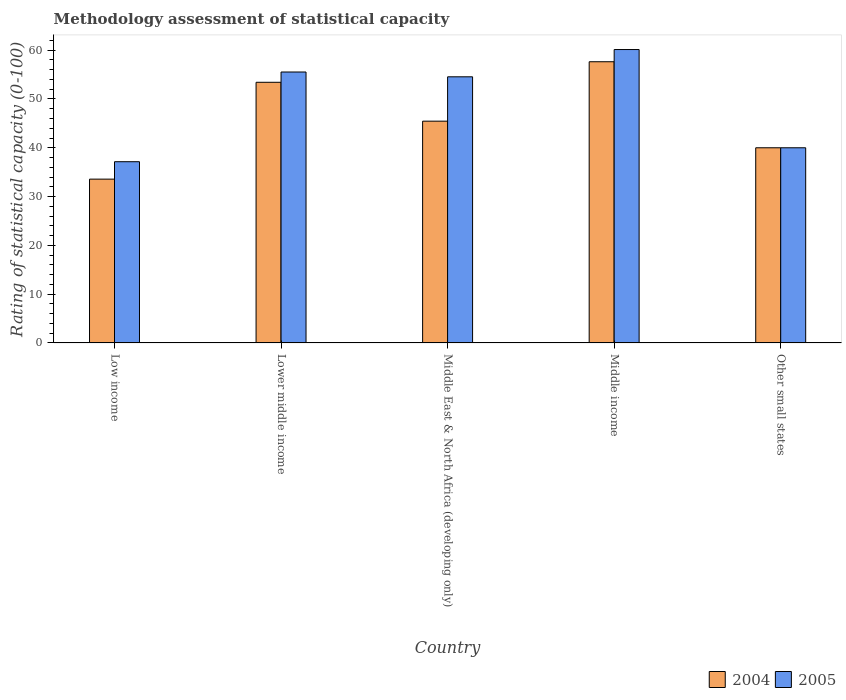How many different coloured bars are there?
Your response must be concise. 2. Are the number of bars per tick equal to the number of legend labels?
Provide a succinct answer. Yes. How many bars are there on the 5th tick from the left?
Offer a terse response. 2. How many bars are there on the 4th tick from the right?
Offer a terse response. 2. What is the label of the 5th group of bars from the left?
Keep it short and to the point. Other small states. In how many cases, is the number of bars for a given country not equal to the number of legend labels?
Provide a short and direct response. 0. What is the rating of statistical capacity in 2005 in Lower middle income?
Provide a short and direct response. 55.53. Across all countries, what is the maximum rating of statistical capacity in 2004?
Provide a short and direct response. 57.63. Across all countries, what is the minimum rating of statistical capacity in 2005?
Provide a succinct answer. 37.14. In which country was the rating of statistical capacity in 2004 maximum?
Your answer should be very brief. Middle income. In which country was the rating of statistical capacity in 2004 minimum?
Provide a succinct answer. Low income. What is the total rating of statistical capacity in 2004 in the graph?
Offer a very short reply. 230.08. What is the difference between the rating of statistical capacity in 2004 in Lower middle income and that in Middle income?
Keep it short and to the point. -4.21. What is the difference between the rating of statistical capacity in 2005 in Middle East & North Africa (developing only) and the rating of statistical capacity in 2004 in Lower middle income?
Keep it short and to the point. 1.12. What is the average rating of statistical capacity in 2004 per country?
Your answer should be compact. 46.02. What is the difference between the rating of statistical capacity of/in 2005 and rating of statistical capacity of/in 2004 in Lower middle income?
Keep it short and to the point. 2.11. In how many countries, is the rating of statistical capacity in 2005 greater than 18?
Keep it short and to the point. 5. What is the ratio of the rating of statistical capacity in 2004 in Middle East & North Africa (developing only) to that in Middle income?
Your answer should be compact. 0.79. Is the rating of statistical capacity in 2005 in Low income less than that in Middle income?
Keep it short and to the point. Yes. Is the difference between the rating of statistical capacity in 2005 in Middle income and Other small states greater than the difference between the rating of statistical capacity in 2004 in Middle income and Other small states?
Your answer should be compact. Yes. What is the difference between the highest and the second highest rating of statistical capacity in 2004?
Your answer should be very brief. 12.18. What is the difference between the highest and the lowest rating of statistical capacity in 2005?
Provide a succinct answer. 22.99. Is the sum of the rating of statistical capacity in 2004 in Low income and Lower middle income greater than the maximum rating of statistical capacity in 2005 across all countries?
Offer a very short reply. Yes. How many bars are there?
Make the answer very short. 10. What is the difference between two consecutive major ticks on the Y-axis?
Ensure brevity in your answer.  10. Are the values on the major ticks of Y-axis written in scientific E-notation?
Provide a short and direct response. No. Does the graph contain any zero values?
Provide a short and direct response. No. Where does the legend appear in the graph?
Provide a short and direct response. Bottom right. What is the title of the graph?
Your answer should be compact. Methodology assessment of statistical capacity. What is the label or title of the Y-axis?
Your response must be concise. Rating of statistical capacity (0-100). What is the Rating of statistical capacity (0-100) in 2004 in Low income?
Your answer should be compact. 33.57. What is the Rating of statistical capacity (0-100) of 2005 in Low income?
Give a very brief answer. 37.14. What is the Rating of statistical capacity (0-100) of 2004 in Lower middle income?
Provide a short and direct response. 53.42. What is the Rating of statistical capacity (0-100) in 2005 in Lower middle income?
Keep it short and to the point. 55.53. What is the Rating of statistical capacity (0-100) of 2004 in Middle East & North Africa (developing only)?
Offer a very short reply. 45.45. What is the Rating of statistical capacity (0-100) in 2005 in Middle East & North Africa (developing only)?
Give a very brief answer. 54.55. What is the Rating of statistical capacity (0-100) of 2004 in Middle income?
Give a very brief answer. 57.63. What is the Rating of statistical capacity (0-100) in 2005 in Middle income?
Your answer should be very brief. 60.13. What is the Rating of statistical capacity (0-100) in 2004 in Other small states?
Your answer should be very brief. 40. What is the Rating of statistical capacity (0-100) of 2005 in Other small states?
Give a very brief answer. 40. Across all countries, what is the maximum Rating of statistical capacity (0-100) in 2004?
Provide a succinct answer. 57.63. Across all countries, what is the maximum Rating of statistical capacity (0-100) of 2005?
Provide a short and direct response. 60.13. Across all countries, what is the minimum Rating of statistical capacity (0-100) in 2004?
Give a very brief answer. 33.57. Across all countries, what is the minimum Rating of statistical capacity (0-100) of 2005?
Provide a succinct answer. 37.14. What is the total Rating of statistical capacity (0-100) of 2004 in the graph?
Offer a very short reply. 230.08. What is the total Rating of statistical capacity (0-100) in 2005 in the graph?
Keep it short and to the point. 247.35. What is the difference between the Rating of statistical capacity (0-100) of 2004 in Low income and that in Lower middle income?
Give a very brief answer. -19.85. What is the difference between the Rating of statistical capacity (0-100) of 2005 in Low income and that in Lower middle income?
Your answer should be very brief. -18.38. What is the difference between the Rating of statistical capacity (0-100) in 2004 in Low income and that in Middle East & North Africa (developing only)?
Your answer should be very brief. -11.88. What is the difference between the Rating of statistical capacity (0-100) in 2005 in Low income and that in Middle East & North Africa (developing only)?
Ensure brevity in your answer.  -17.4. What is the difference between the Rating of statistical capacity (0-100) of 2004 in Low income and that in Middle income?
Your answer should be compact. -24.06. What is the difference between the Rating of statistical capacity (0-100) of 2005 in Low income and that in Middle income?
Provide a succinct answer. -22.99. What is the difference between the Rating of statistical capacity (0-100) in 2004 in Low income and that in Other small states?
Your response must be concise. -6.43. What is the difference between the Rating of statistical capacity (0-100) in 2005 in Low income and that in Other small states?
Offer a terse response. -2.86. What is the difference between the Rating of statistical capacity (0-100) of 2004 in Lower middle income and that in Middle East & North Africa (developing only)?
Ensure brevity in your answer.  7.97. What is the difference between the Rating of statistical capacity (0-100) of 2005 in Lower middle income and that in Middle East & North Africa (developing only)?
Offer a terse response. 0.98. What is the difference between the Rating of statistical capacity (0-100) in 2004 in Lower middle income and that in Middle income?
Offer a terse response. -4.21. What is the difference between the Rating of statistical capacity (0-100) of 2005 in Lower middle income and that in Middle income?
Your answer should be very brief. -4.61. What is the difference between the Rating of statistical capacity (0-100) in 2004 in Lower middle income and that in Other small states?
Your answer should be compact. 13.42. What is the difference between the Rating of statistical capacity (0-100) of 2005 in Lower middle income and that in Other small states?
Your response must be concise. 15.53. What is the difference between the Rating of statistical capacity (0-100) of 2004 in Middle East & North Africa (developing only) and that in Middle income?
Ensure brevity in your answer.  -12.18. What is the difference between the Rating of statistical capacity (0-100) in 2005 in Middle East & North Africa (developing only) and that in Middle income?
Your response must be concise. -5.59. What is the difference between the Rating of statistical capacity (0-100) of 2004 in Middle East & North Africa (developing only) and that in Other small states?
Make the answer very short. 5.45. What is the difference between the Rating of statistical capacity (0-100) of 2005 in Middle East & North Africa (developing only) and that in Other small states?
Make the answer very short. 14.55. What is the difference between the Rating of statistical capacity (0-100) of 2004 in Middle income and that in Other small states?
Your answer should be very brief. 17.63. What is the difference between the Rating of statistical capacity (0-100) of 2005 in Middle income and that in Other small states?
Your response must be concise. 20.13. What is the difference between the Rating of statistical capacity (0-100) in 2004 in Low income and the Rating of statistical capacity (0-100) in 2005 in Lower middle income?
Your answer should be compact. -21.95. What is the difference between the Rating of statistical capacity (0-100) in 2004 in Low income and the Rating of statistical capacity (0-100) in 2005 in Middle East & North Africa (developing only)?
Give a very brief answer. -20.97. What is the difference between the Rating of statistical capacity (0-100) of 2004 in Low income and the Rating of statistical capacity (0-100) of 2005 in Middle income?
Offer a very short reply. -26.56. What is the difference between the Rating of statistical capacity (0-100) of 2004 in Low income and the Rating of statistical capacity (0-100) of 2005 in Other small states?
Offer a terse response. -6.43. What is the difference between the Rating of statistical capacity (0-100) in 2004 in Lower middle income and the Rating of statistical capacity (0-100) in 2005 in Middle East & North Africa (developing only)?
Your response must be concise. -1.12. What is the difference between the Rating of statistical capacity (0-100) of 2004 in Lower middle income and the Rating of statistical capacity (0-100) of 2005 in Middle income?
Offer a very short reply. -6.71. What is the difference between the Rating of statistical capacity (0-100) of 2004 in Lower middle income and the Rating of statistical capacity (0-100) of 2005 in Other small states?
Offer a very short reply. 13.42. What is the difference between the Rating of statistical capacity (0-100) in 2004 in Middle East & North Africa (developing only) and the Rating of statistical capacity (0-100) in 2005 in Middle income?
Your answer should be compact. -14.68. What is the difference between the Rating of statistical capacity (0-100) of 2004 in Middle East & North Africa (developing only) and the Rating of statistical capacity (0-100) of 2005 in Other small states?
Provide a succinct answer. 5.45. What is the difference between the Rating of statistical capacity (0-100) in 2004 in Middle income and the Rating of statistical capacity (0-100) in 2005 in Other small states?
Offer a very short reply. 17.63. What is the average Rating of statistical capacity (0-100) in 2004 per country?
Your answer should be very brief. 46.02. What is the average Rating of statistical capacity (0-100) in 2005 per country?
Ensure brevity in your answer.  49.47. What is the difference between the Rating of statistical capacity (0-100) in 2004 and Rating of statistical capacity (0-100) in 2005 in Low income?
Offer a very short reply. -3.57. What is the difference between the Rating of statistical capacity (0-100) of 2004 and Rating of statistical capacity (0-100) of 2005 in Lower middle income?
Offer a very short reply. -2.11. What is the difference between the Rating of statistical capacity (0-100) of 2004 and Rating of statistical capacity (0-100) of 2005 in Middle East & North Africa (developing only)?
Provide a succinct answer. -9.09. What is the ratio of the Rating of statistical capacity (0-100) of 2004 in Low income to that in Lower middle income?
Ensure brevity in your answer.  0.63. What is the ratio of the Rating of statistical capacity (0-100) in 2005 in Low income to that in Lower middle income?
Your response must be concise. 0.67. What is the ratio of the Rating of statistical capacity (0-100) of 2004 in Low income to that in Middle East & North Africa (developing only)?
Your response must be concise. 0.74. What is the ratio of the Rating of statistical capacity (0-100) of 2005 in Low income to that in Middle East & North Africa (developing only)?
Provide a succinct answer. 0.68. What is the ratio of the Rating of statistical capacity (0-100) in 2004 in Low income to that in Middle income?
Provide a succinct answer. 0.58. What is the ratio of the Rating of statistical capacity (0-100) in 2005 in Low income to that in Middle income?
Offer a very short reply. 0.62. What is the ratio of the Rating of statistical capacity (0-100) of 2004 in Low income to that in Other small states?
Make the answer very short. 0.84. What is the ratio of the Rating of statistical capacity (0-100) in 2004 in Lower middle income to that in Middle East & North Africa (developing only)?
Provide a short and direct response. 1.18. What is the ratio of the Rating of statistical capacity (0-100) of 2004 in Lower middle income to that in Middle income?
Your answer should be very brief. 0.93. What is the ratio of the Rating of statistical capacity (0-100) of 2005 in Lower middle income to that in Middle income?
Ensure brevity in your answer.  0.92. What is the ratio of the Rating of statistical capacity (0-100) in 2004 in Lower middle income to that in Other small states?
Offer a very short reply. 1.34. What is the ratio of the Rating of statistical capacity (0-100) in 2005 in Lower middle income to that in Other small states?
Provide a short and direct response. 1.39. What is the ratio of the Rating of statistical capacity (0-100) of 2004 in Middle East & North Africa (developing only) to that in Middle income?
Offer a terse response. 0.79. What is the ratio of the Rating of statistical capacity (0-100) in 2005 in Middle East & North Africa (developing only) to that in Middle income?
Offer a very short reply. 0.91. What is the ratio of the Rating of statistical capacity (0-100) in 2004 in Middle East & North Africa (developing only) to that in Other small states?
Give a very brief answer. 1.14. What is the ratio of the Rating of statistical capacity (0-100) in 2005 in Middle East & North Africa (developing only) to that in Other small states?
Your answer should be compact. 1.36. What is the ratio of the Rating of statistical capacity (0-100) in 2004 in Middle income to that in Other small states?
Offer a very short reply. 1.44. What is the ratio of the Rating of statistical capacity (0-100) of 2005 in Middle income to that in Other small states?
Provide a short and direct response. 1.5. What is the difference between the highest and the second highest Rating of statistical capacity (0-100) in 2004?
Give a very brief answer. 4.21. What is the difference between the highest and the second highest Rating of statistical capacity (0-100) of 2005?
Provide a succinct answer. 4.61. What is the difference between the highest and the lowest Rating of statistical capacity (0-100) of 2004?
Provide a succinct answer. 24.06. What is the difference between the highest and the lowest Rating of statistical capacity (0-100) in 2005?
Ensure brevity in your answer.  22.99. 